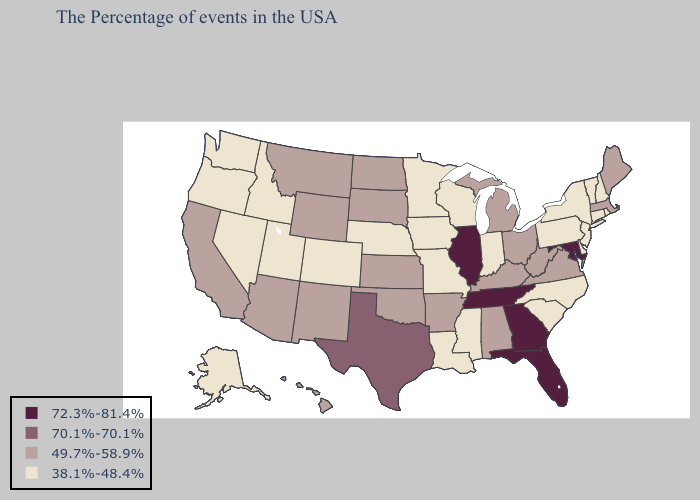What is the highest value in the South ?
Keep it brief. 72.3%-81.4%. Does Arkansas have the same value as Illinois?
Quick response, please. No. Does Florida have the same value as Maryland?
Keep it brief. Yes. Does South Carolina have the same value as Kansas?
Keep it brief. No. What is the value of Wisconsin?
Short answer required. 38.1%-48.4%. What is the value of Michigan?
Give a very brief answer. 49.7%-58.9%. Name the states that have a value in the range 38.1%-48.4%?
Give a very brief answer. Rhode Island, New Hampshire, Vermont, Connecticut, New York, New Jersey, Delaware, Pennsylvania, North Carolina, South Carolina, Indiana, Wisconsin, Mississippi, Louisiana, Missouri, Minnesota, Iowa, Nebraska, Colorado, Utah, Idaho, Nevada, Washington, Oregon, Alaska. What is the value of Wyoming?
Quick response, please. 49.7%-58.9%. Does Illinois have the highest value in the USA?
Keep it brief. Yes. What is the value of New Jersey?
Be succinct. 38.1%-48.4%. Does New Jersey have a lower value than West Virginia?
Be succinct. Yes. Among the states that border Florida , does Georgia have the lowest value?
Short answer required. No. Name the states that have a value in the range 38.1%-48.4%?
Be succinct. Rhode Island, New Hampshire, Vermont, Connecticut, New York, New Jersey, Delaware, Pennsylvania, North Carolina, South Carolina, Indiana, Wisconsin, Mississippi, Louisiana, Missouri, Minnesota, Iowa, Nebraska, Colorado, Utah, Idaho, Nevada, Washington, Oregon, Alaska. Among the states that border Alabama , does Mississippi have the highest value?
Answer briefly. No. 